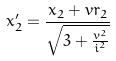<formula> <loc_0><loc_0><loc_500><loc_500>x _ { 2 } ^ { \prime } = \frac { x _ { 2 } + v r _ { 2 } } { \sqrt { 3 + \frac { v ^ { 2 } } { i ^ { 2 } } } }</formula> 